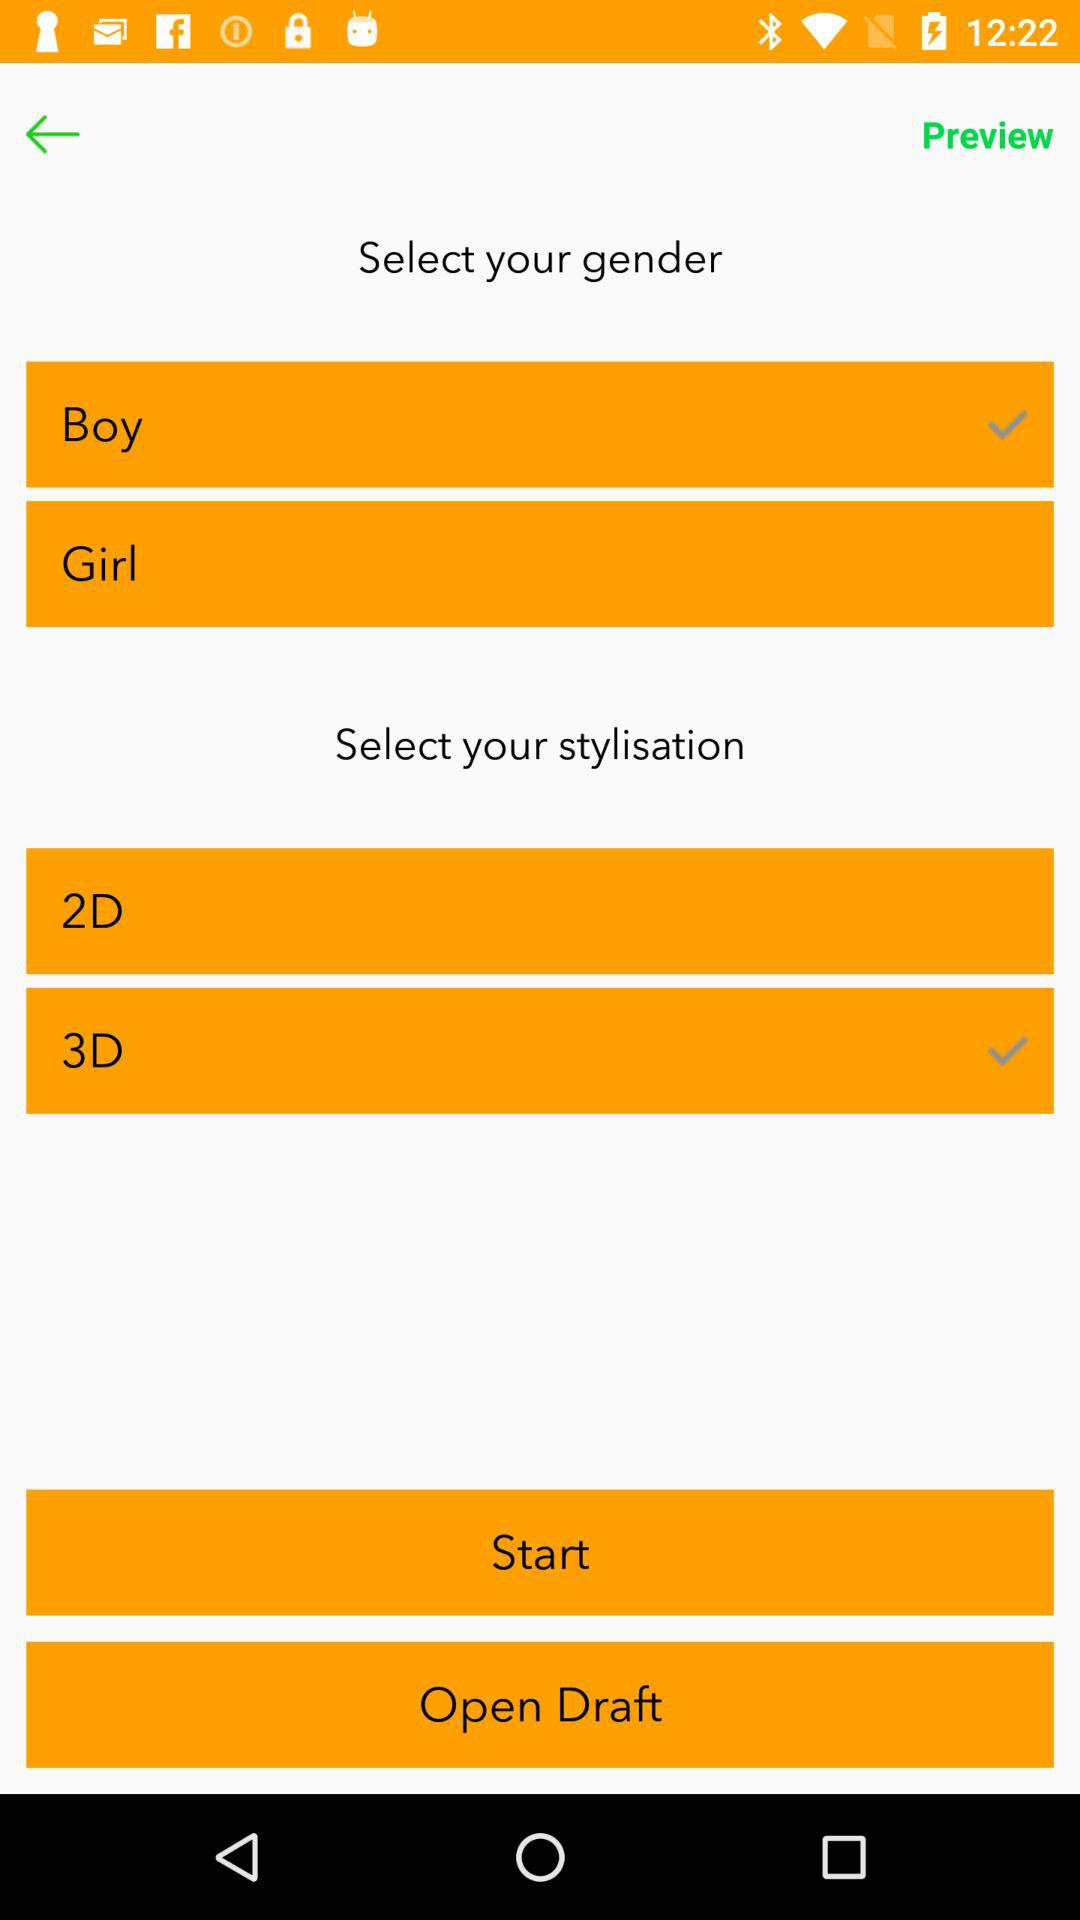What stylisation is selected? The selected stylisation is "3D". 